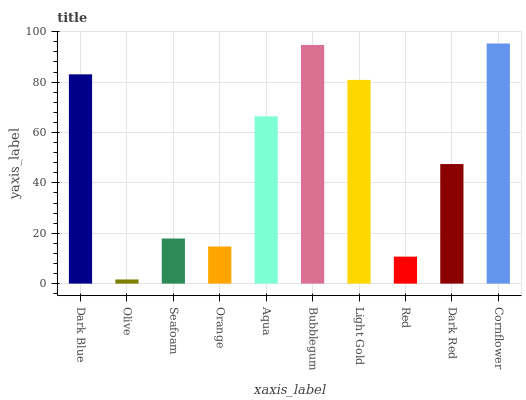Is Olive the minimum?
Answer yes or no. Yes. Is Cornflower the maximum?
Answer yes or no. Yes. Is Seafoam the minimum?
Answer yes or no. No. Is Seafoam the maximum?
Answer yes or no. No. Is Seafoam greater than Olive?
Answer yes or no. Yes. Is Olive less than Seafoam?
Answer yes or no. Yes. Is Olive greater than Seafoam?
Answer yes or no. No. Is Seafoam less than Olive?
Answer yes or no. No. Is Aqua the high median?
Answer yes or no. Yes. Is Dark Red the low median?
Answer yes or no. Yes. Is Cornflower the high median?
Answer yes or no. No. Is Bubblegum the low median?
Answer yes or no. No. 